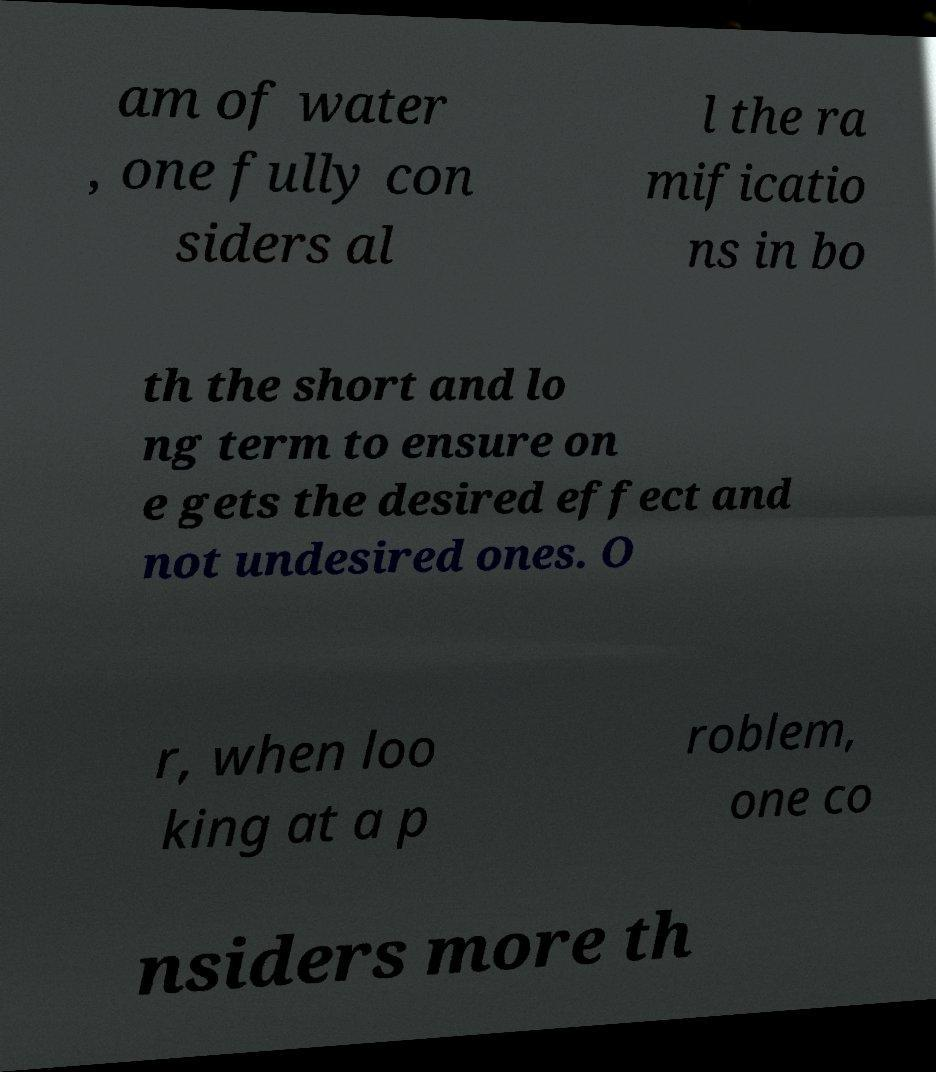For documentation purposes, I need the text within this image transcribed. Could you provide that? am of water , one fully con siders al l the ra mificatio ns in bo th the short and lo ng term to ensure on e gets the desired effect and not undesired ones. O r, when loo king at a p roblem, one co nsiders more th 